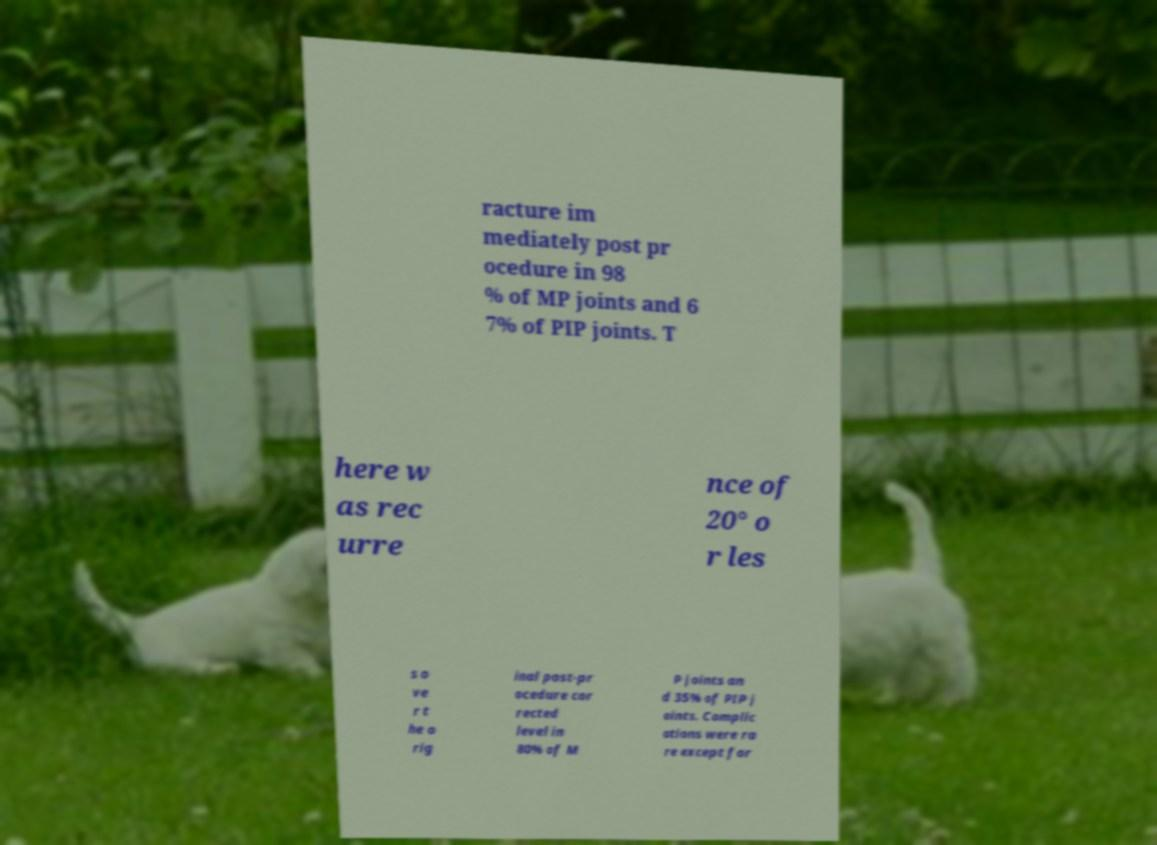Could you assist in decoding the text presented in this image and type it out clearly? racture im mediately post pr ocedure in 98 % of MP joints and 6 7% of PIP joints. T here w as rec urre nce of 20° o r les s o ve r t he o rig inal post-pr ocedure cor rected level in 80% of M P joints an d 35% of PIP j oints. Complic ations were ra re except for 